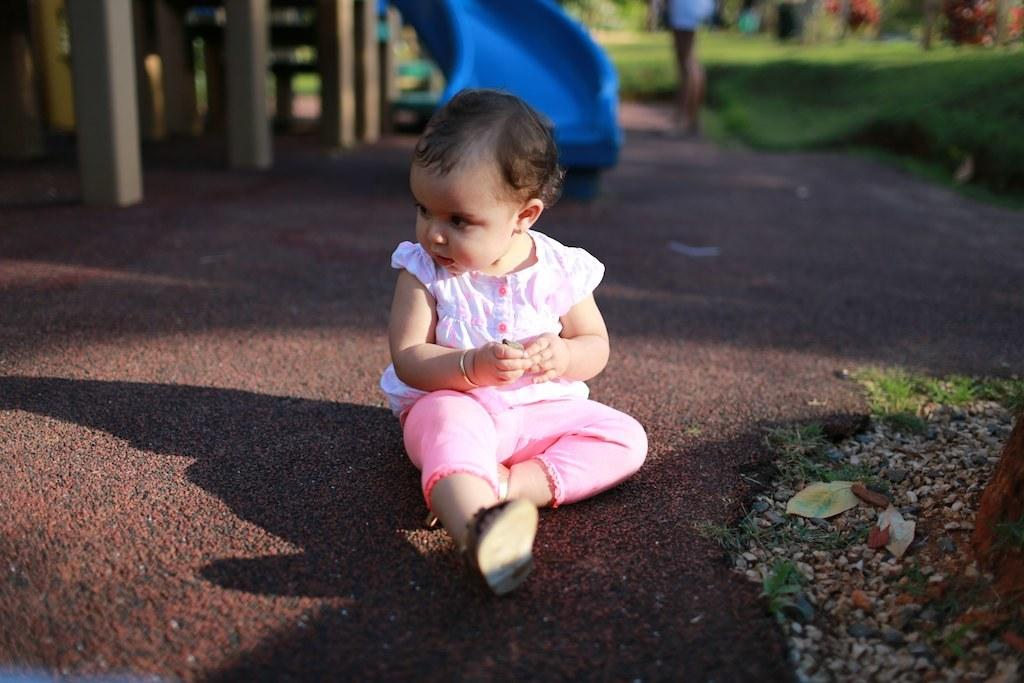What is the child doing in the image? The child is sitting on the ground in the image. What color is the slider visible in the background? The slider in the background is blue. What type of surface is the child sitting on? There is grass visible in the image, so the child is sitting on the grass. How would you describe the background of the image? The background of the image is blurred. What type of dress is the child wearing in the image? There is no dress mentioned in the facts provided, and the image does not show the child wearing a dress. 